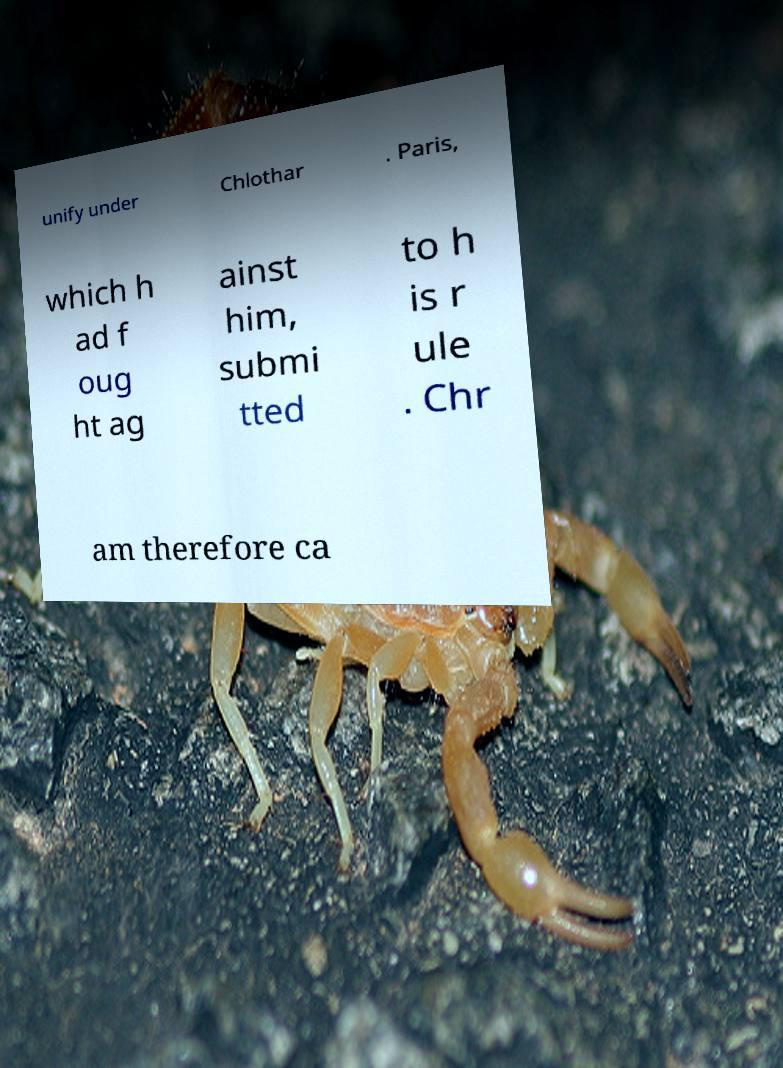Can you read and provide the text displayed in the image?This photo seems to have some interesting text. Can you extract and type it out for me? unify under Chlothar . Paris, which h ad f oug ht ag ainst him, submi tted to h is r ule . Chr am therefore ca 